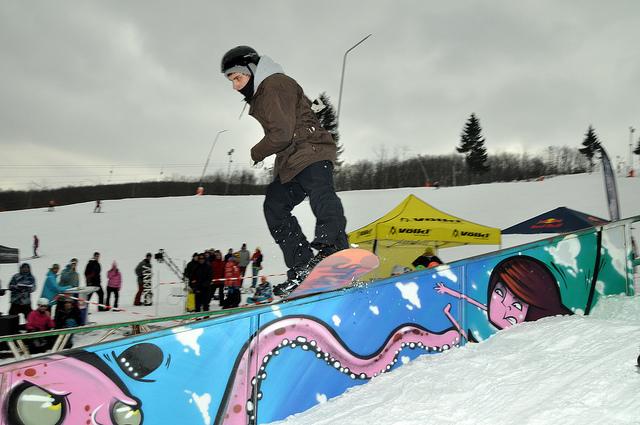Where is the dark neck warmer?
Be succinct. On man. What is the creature on the wall?
Short answer required. Octopus. Is he skateboarding?
Short answer required. No. Is this person relaxed?
Be succinct. No. 